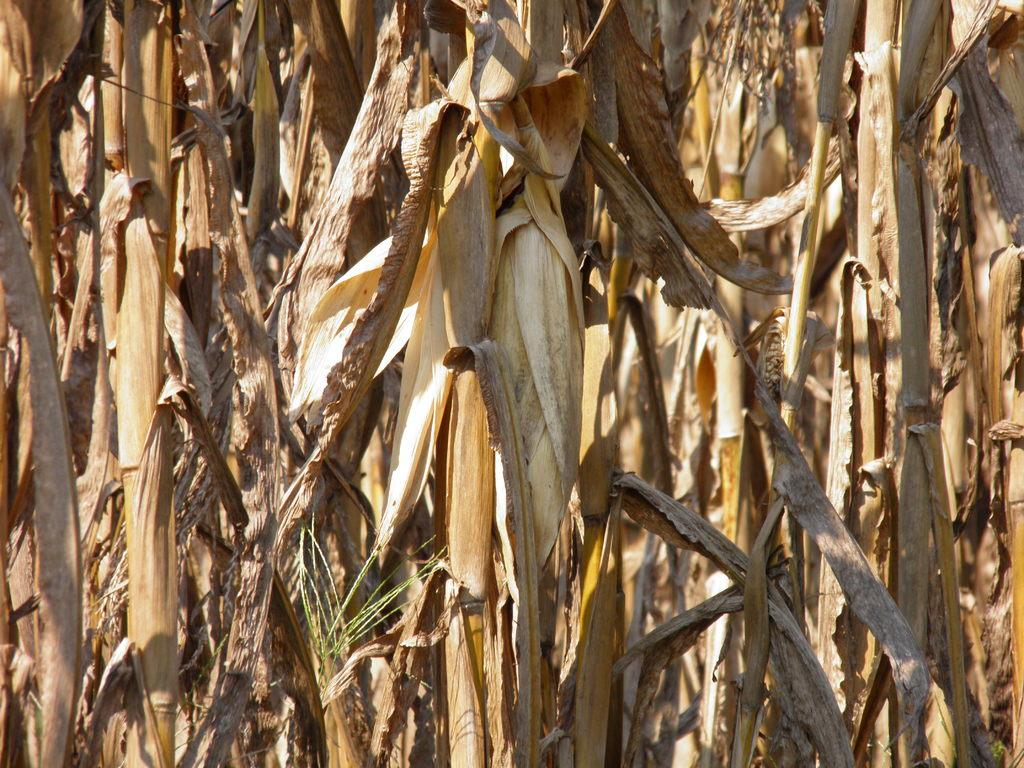What type of crop is visible in the image? There is a dried crop in the image. What is the color of the dried crop? The dried crop is in brown color. What else can be seen in the image besides the dried crop? There are dried leaves in the image. How do the women in the image behave towards the dried crop? There are no women present in the image, so their behavior towards the dried crop cannot be determined. 